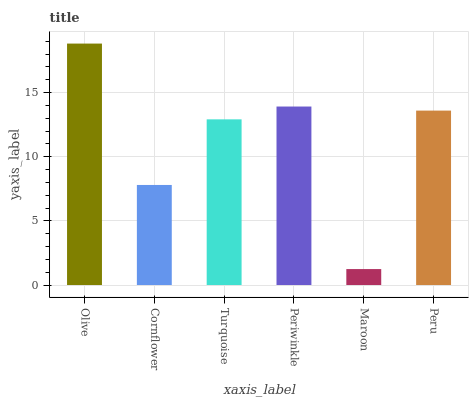Is Maroon the minimum?
Answer yes or no. Yes. Is Olive the maximum?
Answer yes or no. Yes. Is Cornflower the minimum?
Answer yes or no. No. Is Cornflower the maximum?
Answer yes or no. No. Is Olive greater than Cornflower?
Answer yes or no. Yes. Is Cornflower less than Olive?
Answer yes or no. Yes. Is Cornflower greater than Olive?
Answer yes or no. No. Is Olive less than Cornflower?
Answer yes or no. No. Is Peru the high median?
Answer yes or no. Yes. Is Turquoise the low median?
Answer yes or no. Yes. Is Cornflower the high median?
Answer yes or no. No. Is Olive the low median?
Answer yes or no. No. 